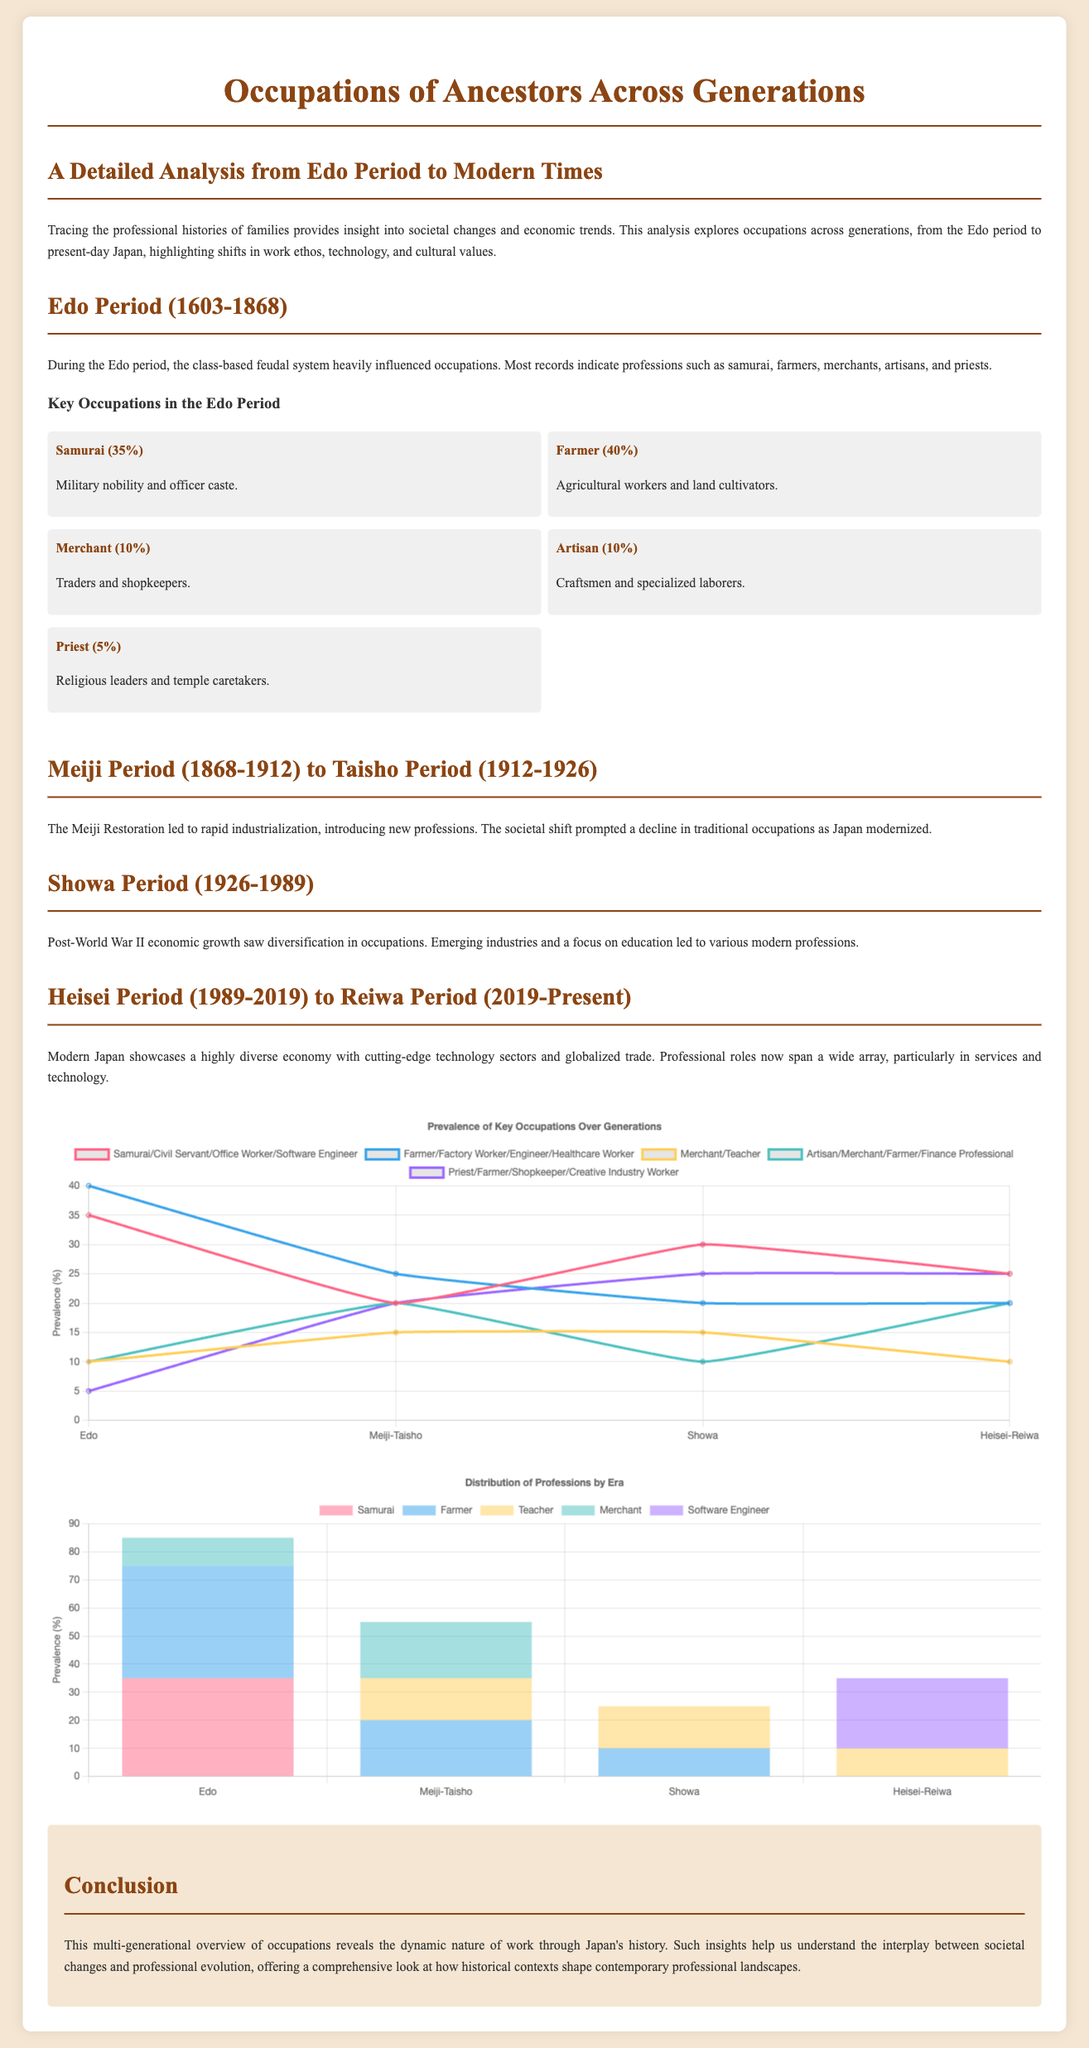What percentage of occupations were samurai during the Edo period? The document states that samurai made up 35% of occupations during the Edo period according to the provided information.
Answer: 35% What category of professions saw a decline during the Meiji period? The professions such as farming and traditional roles diminished as Japan modernized during the Meiji Restoration.
Answer: Traditional occupations Which profession represents the highest percentage in the He'sai-Reiwa period? The chart indicates that software engineers have a prevalence of 25% in the Heisei-Reiwa period.
Answer: Software Engineer What era does the document primarily focus on? The document covers multiple periods, specifically from the Edo period to the contemporary Reiwa period, analyzing generational occupations.
Answer: Edo to Reiwa How many generations are represented in the line chart? The line chart outlines occupational prevalence across four distinct generations or periods.
Answer: Four What was the prevalence percentage of farmers in the Showa period? The document specifies that the percentage of farmers in the Showa period was 20% according to the provided data.
Answer: 20% What change in occupation prevalence is noted during the transition from the Edo period to the Meiji-Taisho period? Occupations such as samurai and farming decreased while modern professions became more recognized during the industrialization phase.
Answer: Decreased Which historical period is characterized by economic growth post-World War II? The Showa period is documented as the time of economic growth following World War II, leading to diverse occupations.
Answer: Showa What type of chart is used to illustrate the distribution of professions by era? The document includes a bar chart to clearly showcase the occupational distribution across various historical periods.
Answer: Bar Chart 